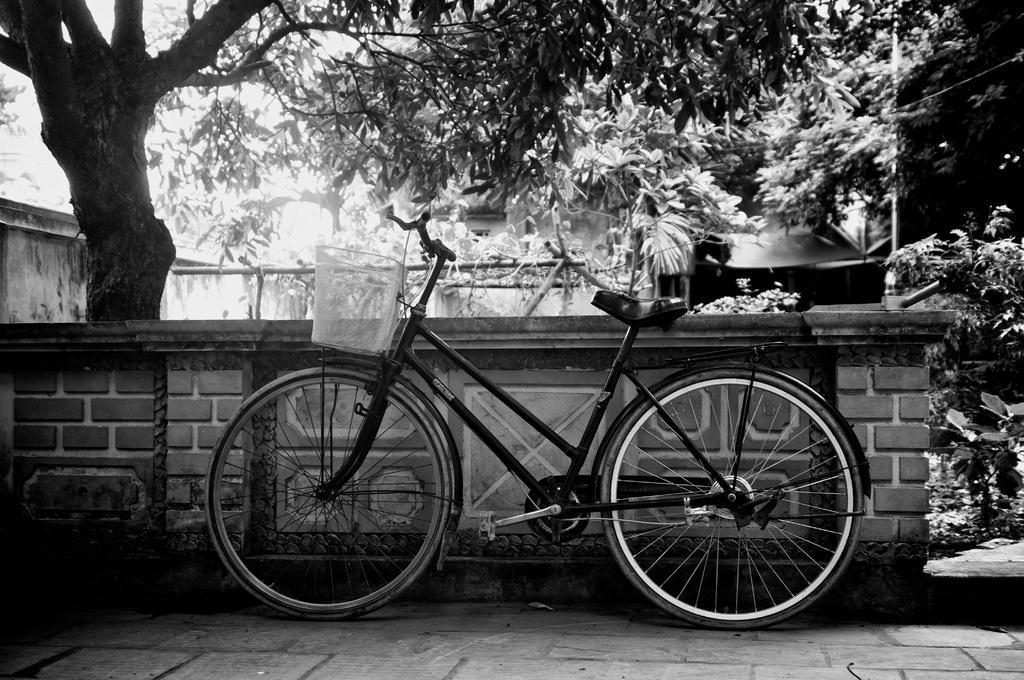Please provide a concise description of this image. In this picture I can observe a bicycle in the middle of the picture. In the background I can observe trees. This is a black and white image. 